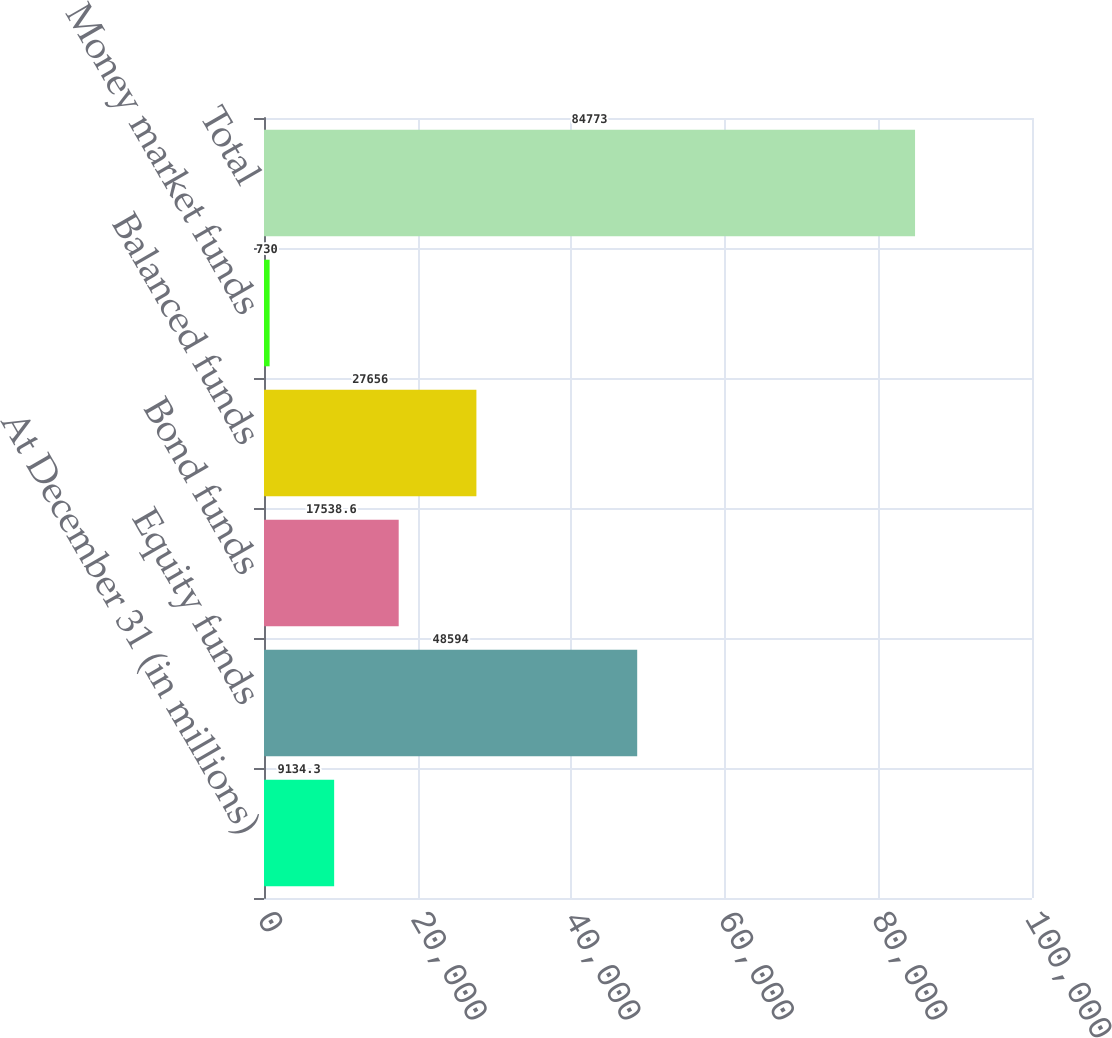<chart> <loc_0><loc_0><loc_500><loc_500><bar_chart><fcel>At December 31 (in millions)<fcel>Equity funds<fcel>Bond funds<fcel>Balanced funds<fcel>Money market funds<fcel>Total<nl><fcel>9134.3<fcel>48594<fcel>17538.6<fcel>27656<fcel>730<fcel>84773<nl></chart> 